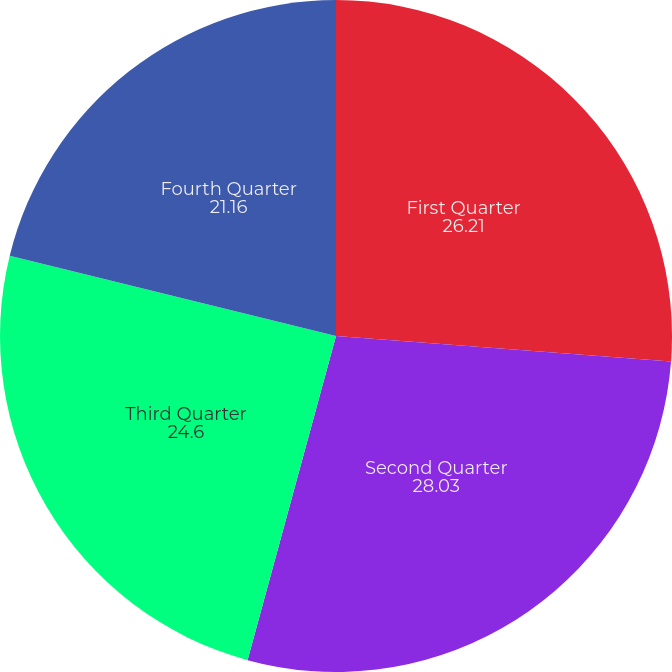Convert chart to OTSL. <chart><loc_0><loc_0><loc_500><loc_500><pie_chart><fcel>First Quarter<fcel>Second Quarter<fcel>Third Quarter<fcel>Fourth Quarter<nl><fcel>26.21%<fcel>28.03%<fcel>24.6%<fcel>21.16%<nl></chart> 